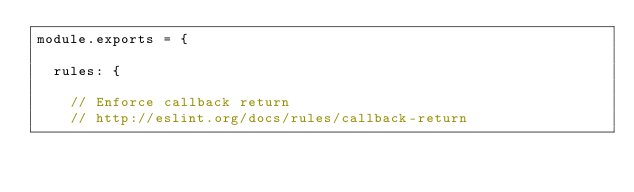<code> <loc_0><loc_0><loc_500><loc_500><_JavaScript_>module.exports = {

  rules: {

    // Enforce callback return
    // http://eslint.org/docs/rules/callback-return</code> 